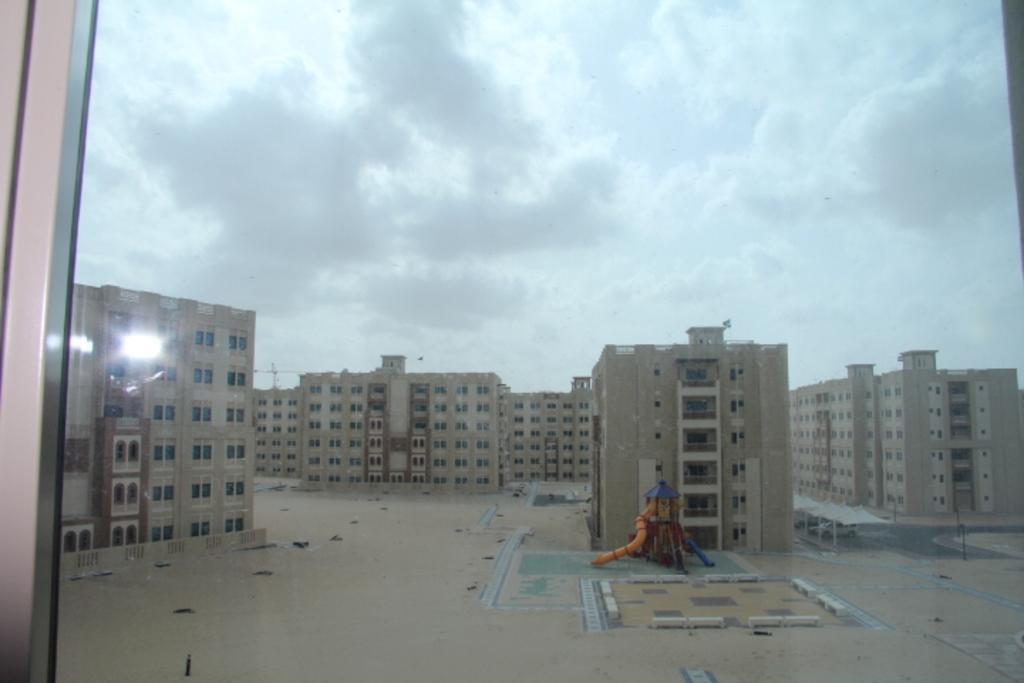Please provide a concise description of this image. In this image I can see the glass window through which I can see few buildings, an object which is orange and blue in color on the ground, few white colored tents and few cars below them and the sky. 